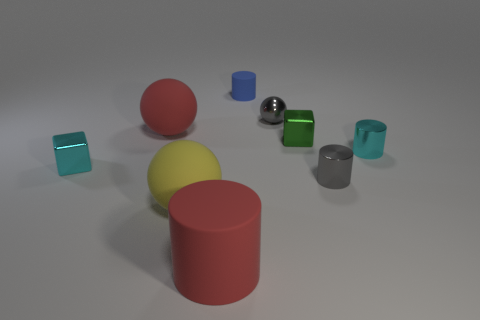Add 1 gray rubber spheres. How many objects exist? 10 Subtract all cubes. How many objects are left? 7 Add 3 yellow balls. How many yellow balls exist? 4 Subtract 0 brown spheres. How many objects are left? 9 Subtract all red matte cylinders. Subtract all large yellow spheres. How many objects are left? 7 Add 1 big red rubber balls. How many big red rubber balls are left? 2 